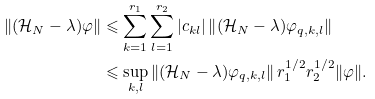<formula> <loc_0><loc_0><loc_500><loc_500>\left \| ( \mathcal { H } _ { N } - \lambda ) \varphi \right \| & \leqslant \sum _ { k = 1 } ^ { r _ { 1 } } \sum _ { l = 1 } ^ { r _ { 2 } } | c _ { k l } | \left \| ( \mathcal { H } _ { N } - \lambda ) \varphi _ { q , k , l } \right \| \\ & \leqslant \underset { k , l } \sup \left \| ( \mathcal { H } _ { N } - \lambda ) \varphi _ { q , k , l } \right \| r _ { 1 } ^ { 1 / 2 } r _ { 2 } ^ { 1 / 2 } \| \varphi \| .</formula> 